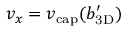<formula> <loc_0><loc_0><loc_500><loc_500>v _ { x } = { v _ { c a p } } ( { b _ { 3 D } ^ { \prime } } )</formula> 